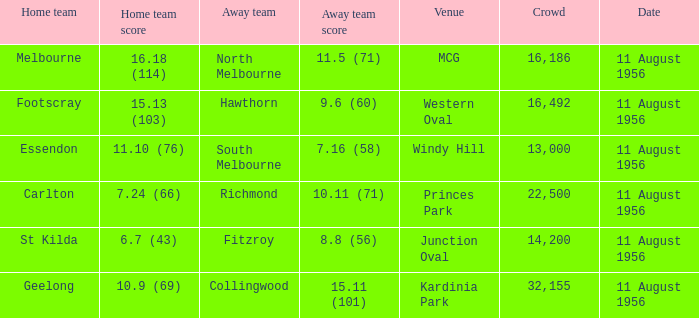What domestic team competed at the western oval? Footscray. 